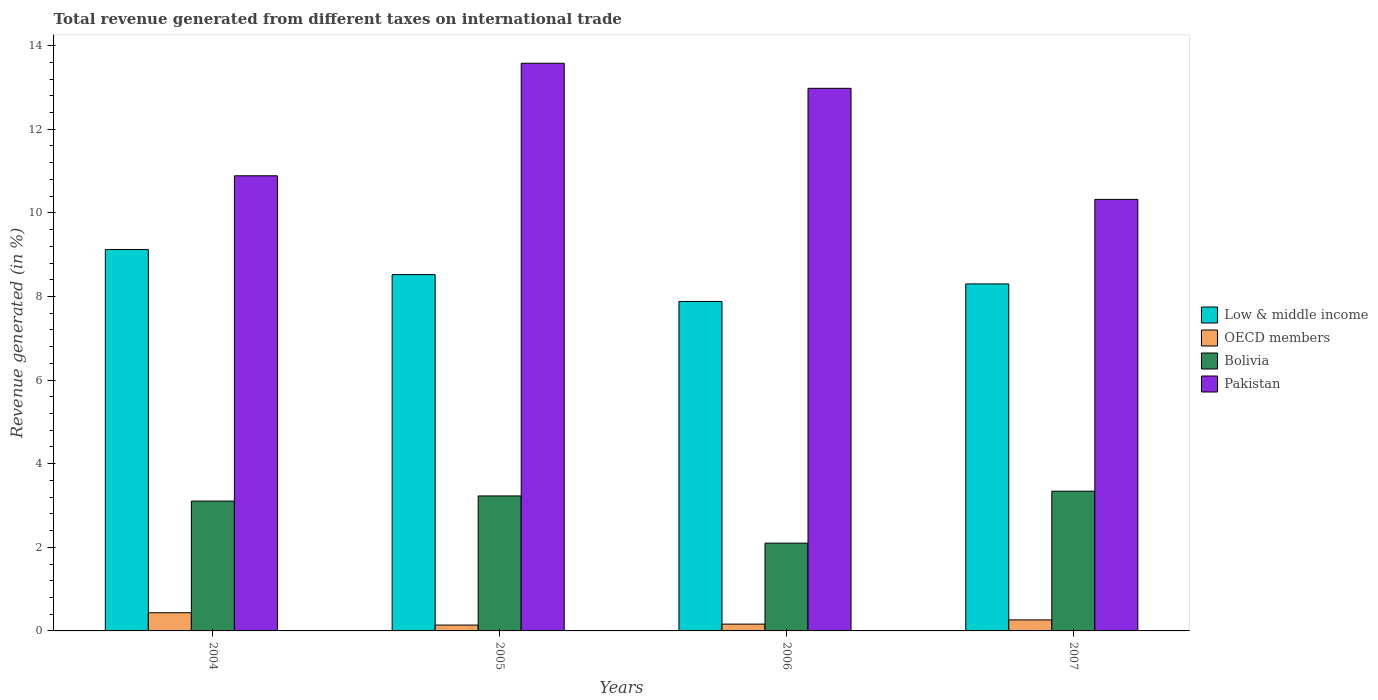Are the number of bars per tick equal to the number of legend labels?
Keep it short and to the point. Yes. In how many cases, is the number of bars for a given year not equal to the number of legend labels?
Your response must be concise. 0. What is the total revenue generated in Low & middle income in 2005?
Offer a very short reply. 8.52. Across all years, what is the maximum total revenue generated in Bolivia?
Your answer should be compact. 3.34. Across all years, what is the minimum total revenue generated in Low & middle income?
Offer a very short reply. 7.88. In which year was the total revenue generated in Bolivia minimum?
Make the answer very short. 2006. What is the total total revenue generated in OECD members in the graph?
Give a very brief answer. 1. What is the difference between the total revenue generated in Low & middle income in 2006 and that in 2007?
Your answer should be compact. -0.42. What is the difference between the total revenue generated in Low & middle income in 2007 and the total revenue generated in Pakistan in 2005?
Provide a succinct answer. -5.28. What is the average total revenue generated in OECD members per year?
Your response must be concise. 0.25. In the year 2005, what is the difference between the total revenue generated in Bolivia and total revenue generated in OECD members?
Offer a terse response. 3.09. What is the ratio of the total revenue generated in Bolivia in 2004 to that in 2006?
Your answer should be very brief. 1.48. Is the total revenue generated in Bolivia in 2006 less than that in 2007?
Your response must be concise. Yes. Is the difference between the total revenue generated in Bolivia in 2005 and 2006 greater than the difference between the total revenue generated in OECD members in 2005 and 2006?
Your answer should be compact. Yes. What is the difference between the highest and the second highest total revenue generated in Pakistan?
Make the answer very short. 0.6. What is the difference between the highest and the lowest total revenue generated in Bolivia?
Your answer should be very brief. 1.24. Is the sum of the total revenue generated in Bolivia in 2006 and 2007 greater than the maximum total revenue generated in OECD members across all years?
Provide a succinct answer. Yes. Is it the case that in every year, the sum of the total revenue generated in Pakistan and total revenue generated in OECD members is greater than the sum of total revenue generated in Low & middle income and total revenue generated in Bolivia?
Give a very brief answer. Yes. What does the 3rd bar from the right in 2005 represents?
Give a very brief answer. OECD members. Is it the case that in every year, the sum of the total revenue generated in OECD members and total revenue generated in Low & middle income is greater than the total revenue generated in Pakistan?
Provide a short and direct response. No. How many bars are there?
Your answer should be very brief. 16. Are the values on the major ticks of Y-axis written in scientific E-notation?
Give a very brief answer. No. What is the title of the graph?
Offer a very short reply. Total revenue generated from different taxes on international trade. What is the label or title of the Y-axis?
Ensure brevity in your answer.  Revenue generated (in %). What is the Revenue generated (in %) in Low & middle income in 2004?
Offer a very short reply. 9.12. What is the Revenue generated (in %) in OECD members in 2004?
Offer a terse response. 0.44. What is the Revenue generated (in %) in Bolivia in 2004?
Provide a succinct answer. 3.11. What is the Revenue generated (in %) of Pakistan in 2004?
Make the answer very short. 10.89. What is the Revenue generated (in %) in Low & middle income in 2005?
Ensure brevity in your answer.  8.52. What is the Revenue generated (in %) of OECD members in 2005?
Your response must be concise. 0.14. What is the Revenue generated (in %) in Bolivia in 2005?
Your response must be concise. 3.23. What is the Revenue generated (in %) in Pakistan in 2005?
Your answer should be compact. 13.58. What is the Revenue generated (in %) of Low & middle income in 2006?
Give a very brief answer. 7.88. What is the Revenue generated (in %) in OECD members in 2006?
Provide a succinct answer. 0.16. What is the Revenue generated (in %) in Bolivia in 2006?
Provide a succinct answer. 2.1. What is the Revenue generated (in %) of Pakistan in 2006?
Provide a short and direct response. 12.98. What is the Revenue generated (in %) of Low & middle income in 2007?
Provide a succinct answer. 8.3. What is the Revenue generated (in %) of OECD members in 2007?
Provide a succinct answer. 0.26. What is the Revenue generated (in %) of Bolivia in 2007?
Provide a short and direct response. 3.34. What is the Revenue generated (in %) in Pakistan in 2007?
Make the answer very short. 10.32. Across all years, what is the maximum Revenue generated (in %) of Low & middle income?
Offer a very short reply. 9.12. Across all years, what is the maximum Revenue generated (in %) of OECD members?
Offer a very short reply. 0.44. Across all years, what is the maximum Revenue generated (in %) of Bolivia?
Provide a succinct answer. 3.34. Across all years, what is the maximum Revenue generated (in %) in Pakistan?
Keep it short and to the point. 13.58. Across all years, what is the minimum Revenue generated (in %) of Low & middle income?
Your response must be concise. 7.88. Across all years, what is the minimum Revenue generated (in %) in OECD members?
Give a very brief answer. 0.14. Across all years, what is the minimum Revenue generated (in %) in Bolivia?
Your answer should be compact. 2.1. Across all years, what is the minimum Revenue generated (in %) of Pakistan?
Offer a very short reply. 10.32. What is the total Revenue generated (in %) of Low & middle income in the graph?
Your answer should be very brief. 33.83. What is the total Revenue generated (in %) of OECD members in the graph?
Give a very brief answer. 1. What is the total Revenue generated (in %) of Bolivia in the graph?
Make the answer very short. 11.78. What is the total Revenue generated (in %) of Pakistan in the graph?
Your answer should be compact. 47.77. What is the difference between the Revenue generated (in %) of Low & middle income in 2004 and that in 2005?
Keep it short and to the point. 0.6. What is the difference between the Revenue generated (in %) of OECD members in 2004 and that in 2005?
Make the answer very short. 0.3. What is the difference between the Revenue generated (in %) of Bolivia in 2004 and that in 2005?
Offer a terse response. -0.12. What is the difference between the Revenue generated (in %) of Pakistan in 2004 and that in 2005?
Provide a short and direct response. -2.69. What is the difference between the Revenue generated (in %) of Low & middle income in 2004 and that in 2006?
Keep it short and to the point. 1.24. What is the difference between the Revenue generated (in %) in OECD members in 2004 and that in 2006?
Your answer should be very brief. 0.27. What is the difference between the Revenue generated (in %) of Bolivia in 2004 and that in 2006?
Keep it short and to the point. 1.01. What is the difference between the Revenue generated (in %) of Pakistan in 2004 and that in 2006?
Give a very brief answer. -2.09. What is the difference between the Revenue generated (in %) in Low & middle income in 2004 and that in 2007?
Give a very brief answer. 0.82. What is the difference between the Revenue generated (in %) in OECD members in 2004 and that in 2007?
Your answer should be compact. 0.17. What is the difference between the Revenue generated (in %) in Bolivia in 2004 and that in 2007?
Offer a very short reply. -0.24. What is the difference between the Revenue generated (in %) of Pakistan in 2004 and that in 2007?
Give a very brief answer. 0.56. What is the difference between the Revenue generated (in %) in Low & middle income in 2005 and that in 2006?
Offer a terse response. 0.64. What is the difference between the Revenue generated (in %) in OECD members in 2005 and that in 2006?
Keep it short and to the point. -0.02. What is the difference between the Revenue generated (in %) of Bolivia in 2005 and that in 2006?
Offer a very short reply. 1.13. What is the difference between the Revenue generated (in %) in Pakistan in 2005 and that in 2006?
Your answer should be very brief. 0.6. What is the difference between the Revenue generated (in %) of Low & middle income in 2005 and that in 2007?
Your response must be concise. 0.22. What is the difference between the Revenue generated (in %) of OECD members in 2005 and that in 2007?
Ensure brevity in your answer.  -0.12. What is the difference between the Revenue generated (in %) of Bolivia in 2005 and that in 2007?
Make the answer very short. -0.11. What is the difference between the Revenue generated (in %) in Pakistan in 2005 and that in 2007?
Keep it short and to the point. 3.26. What is the difference between the Revenue generated (in %) in Low & middle income in 2006 and that in 2007?
Your answer should be very brief. -0.42. What is the difference between the Revenue generated (in %) in OECD members in 2006 and that in 2007?
Give a very brief answer. -0.1. What is the difference between the Revenue generated (in %) in Bolivia in 2006 and that in 2007?
Provide a succinct answer. -1.24. What is the difference between the Revenue generated (in %) in Pakistan in 2006 and that in 2007?
Offer a terse response. 2.66. What is the difference between the Revenue generated (in %) of Low & middle income in 2004 and the Revenue generated (in %) of OECD members in 2005?
Offer a terse response. 8.98. What is the difference between the Revenue generated (in %) of Low & middle income in 2004 and the Revenue generated (in %) of Bolivia in 2005?
Provide a succinct answer. 5.89. What is the difference between the Revenue generated (in %) of Low & middle income in 2004 and the Revenue generated (in %) of Pakistan in 2005?
Offer a terse response. -4.46. What is the difference between the Revenue generated (in %) in OECD members in 2004 and the Revenue generated (in %) in Bolivia in 2005?
Your response must be concise. -2.79. What is the difference between the Revenue generated (in %) of OECD members in 2004 and the Revenue generated (in %) of Pakistan in 2005?
Offer a terse response. -13.14. What is the difference between the Revenue generated (in %) in Bolivia in 2004 and the Revenue generated (in %) in Pakistan in 2005?
Offer a very short reply. -10.47. What is the difference between the Revenue generated (in %) of Low & middle income in 2004 and the Revenue generated (in %) of OECD members in 2006?
Offer a very short reply. 8.96. What is the difference between the Revenue generated (in %) of Low & middle income in 2004 and the Revenue generated (in %) of Bolivia in 2006?
Keep it short and to the point. 7.02. What is the difference between the Revenue generated (in %) of Low & middle income in 2004 and the Revenue generated (in %) of Pakistan in 2006?
Keep it short and to the point. -3.86. What is the difference between the Revenue generated (in %) of OECD members in 2004 and the Revenue generated (in %) of Bolivia in 2006?
Your answer should be compact. -1.66. What is the difference between the Revenue generated (in %) in OECD members in 2004 and the Revenue generated (in %) in Pakistan in 2006?
Give a very brief answer. -12.54. What is the difference between the Revenue generated (in %) in Bolivia in 2004 and the Revenue generated (in %) in Pakistan in 2006?
Provide a succinct answer. -9.87. What is the difference between the Revenue generated (in %) of Low & middle income in 2004 and the Revenue generated (in %) of OECD members in 2007?
Keep it short and to the point. 8.86. What is the difference between the Revenue generated (in %) of Low & middle income in 2004 and the Revenue generated (in %) of Bolivia in 2007?
Offer a terse response. 5.78. What is the difference between the Revenue generated (in %) of Low & middle income in 2004 and the Revenue generated (in %) of Pakistan in 2007?
Offer a very short reply. -1.2. What is the difference between the Revenue generated (in %) of OECD members in 2004 and the Revenue generated (in %) of Bolivia in 2007?
Provide a succinct answer. -2.91. What is the difference between the Revenue generated (in %) of OECD members in 2004 and the Revenue generated (in %) of Pakistan in 2007?
Offer a very short reply. -9.89. What is the difference between the Revenue generated (in %) of Bolivia in 2004 and the Revenue generated (in %) of Pakistan in 2007?
Your answer should be compact. -7.22. What is the difference between the Revenue generated (in %) in Low & middle income in 2005 and the Revenue generated (in %) in OECD members in 2006?
Your answer should be compact. 8.36. What is the difference between the Revenue generated (in %) in Low & middle income in 2005 and the Revenue generated (in %) in Bolivia in 2006?
Offer a terse response. 6.42. What is the difference between the Revenue generated (in %) of Low & middle income in 2005 and the Revenue generated (in %) of Pakistan in 2006?
Your response must be concise. -4.46. What is the difference between the Revenue generated (in %) in OECD members in 2005 and the Revenue generated (in %) in Bolivia in 2006?
Ensure brevity in your answer.  -1.96. What is the difference between the Revenue generated (in %) of OECD members in 2005 and the Revenue generated (in %) of Pakistan in 2006?
Keep it short and to the point. -12.84. What is the difference between the Revenue generated (in %) in Bolivia in 2005 and the Revenue generated (in %) in Pakistan in 2006?
Keep it short and to the point. -9.75. What is the difference between the Revenue generated (in %) in Low & middle income in 2005 and the Revenue generated (in %) in OECD members in 2007?
Your answer should be compact. 8.26. What is the difference between the Revenue generated (in %) of Low & middle income in 2005 and the Revenue generated (in %) of Bolivia in 2007?
Give a very brief answer. 5.18. What is the difference between the Revenue generated (in %) of Low & middle income in 2005 and the Revenue generated (in %) of Pakistan in 2007?
Your response must be concise. -1.8. What is the difference between the Revenue generated (in %) of OECD members in 2005 and the Revenue generated (in %) of Bolivia in 2007?
Your response must be concise. -3.2. What is the difference between the Revenue generated (in %) of OECD members in 2005 and the Revenue generated (in %) of Pakistan in 2007?
Your response must be concise. -10.18. What is the difference between the Revenue generated (in %) of Bolivia in 2005 and the Revenue generated (in %) of Pakistan in 2007?
Give a very brief answer. -7.09. What is the difference between the Revenue generated (in %) in Low & middle income in 2006 and the Revenue generated (in %) in OECD members in 2007?
Provide a succinct answer. 7.62. What is the difference between the Revenue generated (in %) of Low & middle income in 2006 and the Revenue generated (in %) of Bolivia in 2007?
Provide a short and direct response. 4.54. What is the difference between the Revenue generated (in %) of Low & middle income in 2006 and the Revenue generated (in %) of Pakistan in 2007?
Provide a succinct answer. -2.44. What is the difference between the Revenue generated (in %) of OECD members in 2006 and the Revenue generated (in %) of Bolivia in 2007?
Offer a very short reply. -3.18. What is the difference between the Revenue generated (in %) in OECD members in 2006 and the Revenue generated (in %) in Pakistan in 2007?
Your response must be concise. -10.16. What is the difference between the Revenue generated (in %) of Bolivia in 2006 and the Revenue generated (in %) of Pakistan in 2007?
Ensure brevity in your answer.  -8.22. What is the average Revenue generated (in %) in Low & middle income per year?
Your answer should be very brief. 8.46. What is the average Revenue generated (in %) in OECD members per year?
Ensure brevity in your answer.  0.25. What is the average Revenue generated (in %) in Bolivia per year?
Keep it short and to the point. 2.94. What is the average Revenue generated (in %) in Pakistan per year?
Provide a short and direct response. 11.94. In the year 2004, what is the difference between the Revenue generated (in %) of Low & middle income and Revenue generated (in %) of OECD members?
Offer a very short reply. 8.69. In the year 2004, what is the difference between the Revenue generated (in %) of Low & middle income and Revenue generated (in %) of Bolivia?
Make the answer very short. 6.02. In the year 2004, what is the difference between the Revenue generated (in %) in Low & middle income and Revenue generated (in %) in Pakistan?
Make the answer very short. -1.76. In the year 2004, what is the difference between the Revenue generated (in %) of OECD members and Revenue generated (in %) of Bolivia?
Give a very brief answer. -2.67. In the year 2004, what is the difference between the Revenue generated (in %) in OECD members and Revenue generated (in %) in Pakistan?
Your answer should be compact. -10.45. In the year 2004, what is the difference between the Revenue generated (in %) in Bolivia and Revenue generated (in %) in Pakistan?
Ensure brevity in your answer.  -7.78. In the year 2005, what is the difference between the Revenue generated (in %) of Low & middle income and Revenue generated (in %) of OECD members?
Offer a terse response. 8.38. In the year 2005, what is the difference between the Revenue generated (in %) in Low & middle income and Revenue generated (in %) in Bolivia?
Give a very brief answer. 5.29. In the year 2005, what is the difference between the Revenue generated (in %) in Low & middle income and Revenue generated (in %) in Pakistan?
Provide a short and direct response. -5.06. In the year 2005, what is the difference between the Revenue generated (in %) of OECD members and Revenue generated (in %) of Bolivia?
Keep it short and to the point. -3.09. In the year 2005, what is the difference between the Revenue generated (in %) of OECD members and Revenue generated (in %) of Pakistan?
Offer a terse response. -13.44. In the year 2005, what is the difference between the Revenue generated (in %) in Bolivia and Revenue generated (in %) in Pakistan?
Provide a short and direct response. -10.35. In the year 2006, what is the difference between the Revenue generated (in %) in Low & middle income and Revenue generated (in %) in OECD members?
Give a very brief answer. 7.72. In the year 2006, what is the difference between the Revenue generated (in %) of Low & middle income and Revenue generated (in %) of Bolivia?
Offer a very short reply. 5.78. In the year 2006, what is the difference between the Revenue generated (in %) of Low & middle income and Revenue generated (in %) of Pakistan?
Offer a terse response. -5.1. In the year 2006, what is the difference between the Revenue generated (in %) of OECD members and Revenue generated (in %) of Bolivia?
Offer a very short reply. -1.94. In the year 2006, what is the difference between the Revenue generated (in %) of OECD members and Revenue generated (in %) of Pakistan?
Your answer should be compact. -12.82. In the year 2006, what is the difference between the Revenue generated (in %) in Bolivia and Revenue generated (in %) in Pakistan?
Your answer should be very brief. -10.88. In the year 2007, what is the difference between the Revenue generated (in %) in Low & middle income and Revenue generated (in %) in OECD members?
Provide a succinct answer. 8.04. In the year 2007, what is the difference between the Revenue generated (in %) in Low & middle income and Revenue generated (in %) in Bolivia?
Keep it short and to the point. 4.96. In the year 2007, what is the difference between the Revenue generated (in %) in Low & middle income and Revenue generated (in %) in Pakistan?
Give a very brief answer. -2.02. In the year 2007, what is the difference between the Revenue generated (in %) of OECD members and Revenue generated (in %) of Bolivia?
Keep it short and to the point. -3.08. In the year 2007, what is the difference between the Revenue generated (in %) in OECD members and Revenue generated (in %) in Pakistan?
Provide a short and direct response. -10.06. In the year 2007, what is the difference between the Revenue generated (in %) in Bolivia and Revenue generated (in %) in Pakistan?
Your answer should be compact. -6.98. What is the ratio of the Revenue generated (in %) in Low & middle income in 2004 to that in 2005?
Provide a succinct answer. 1.07. What is the ratio of the Revenue generated (in %) of OECD members in 2004 to that in 2005?
Ensure brevity in your answer.  3.11. What is the ratio of the Revenue generated (in %) of Bolivia in 2004 to that in 2005?
Offer a terse response. 0.96. What is the ratio of the Revenue generated (in %) of Pakistan in 2004 to that in 2005?
Give a very brief answer. 0.8. What is the ratio of the Revenue generated (in %) in Low & middle income in 2004 to that in 2006?
Your answer should be very brief. 1.16. What is the ratio of the Revenue generated (in %) of OECD members in 2004 to that in 2006?
Give a very brief answer. 2.68. What is the ratio of the Revenue generated (in %) of Bolivia in 2004 to that in 2006?
Offer a very short reply. 1.48. What is the ratio of the Revenue generated (in %) in Pakistan in 2004 to that in 2006?
Provide a succinct answer. 0.84. What is the ratio of the Revenue generated (in %) in Low & middle income in 2004 to that in 2007?
Your answer should be very brief. 1.1. What is the ratio of the Revenue generated (in %) in OECD members in 2004 to that in 2007?
Provide a succinct answer. 1.65. What is the ratio of the Revenue generated (in %) in Bolivia in 2004 to that in 2007?
Offer a very short reply. 0.93. What is the ratio of the Revenue generated (in %) in Pakistan in 2004 to that in 2007?
Make the answer very short. 1.05. What is the ratio of the Revenue generated (in %) of Low & middle income in 2005 to that in 2006?
Your response must be concise. 1.08. What is the ratio of the Revenue generated (in %) of OECD members in 2005 to that in 2006?
Make the answer very short. 0.86. What is the ratio of the Revenue generated (in %) in Bolivia in 2005 to that in 2006?
Keep it short and to the point. 1.54. What is the ratio of the Revenue generated (in %) of Pakistan in 2005 to that in 2006?
Give a very brief answer. 1.05. What is the ratio of the Revenue generated (in %) in Low & middle income in 2005 to that in 2007?
Your answer should be very brief. 1.03. What is the ratio of the Revenue generated (in %) of OECD members in 2005 to that in 2007?
Your response must be concise. 0.53. What is the ratio of the Revenue generated (in %) in Bolivia in 2005 to that in 2007?
Your answer should be very brief. 0.97. What is the ratio of the Revenue generated (in %) in Pakistan in 2005 to that in 2007?
Offer a very short reply. 1.32. What is the ratio of the Revenue generated (in %) of Low & middle income in 2006 to that in 2007?
Provide a succinct answer. 0.95. What is the ratio of the Revenue generated (in %) in OECD members in 2006 to that in 2007?
Ensure brevity in your answer.  0.62. What is the ratio of the Revenue generated (in %) in Bolivia in 2006 to that in 2007?
Give a very brief answer. 0.63. What is the ratio of the Revenue generated (in %) in Pakistan in 2006 to that in 2007?
Give a very brief answer. 1.26. What is the difference between the highest and the second highest Revenue generated (in %) in Low & middle income?
Make the answer very short. 0.6. What is the difference between the highest and the second highest Revenue generated (in %) of OECD members?
Make the answer very short. 0.17. What is the difference between the highest and the second highest Revenue generated (in %) of Bolivia?
Provide a succinct answer. 0.11. What is the difference between the highest and the second highest Revenue generated (in %) of Pakistan?
Provide a succinct answer. 0.6. What is the difference between the highest and the lowest Revenue generated (in %) in Low & middle income?
Give a very brief answer. 1.24. What is the difference between the highest and the lowest Revenue generated (in %) in OECD members?
Offer a very short reply. 0.3. What is the difference between the highest and the lowest Revenue generated (in %) in Bolivia?
Provide a succinct answer. 1.24. What is the difference between the highest and the lowest Revenue generated (in %) of Pakistan?
Provide a short and direct response. 3.26. 